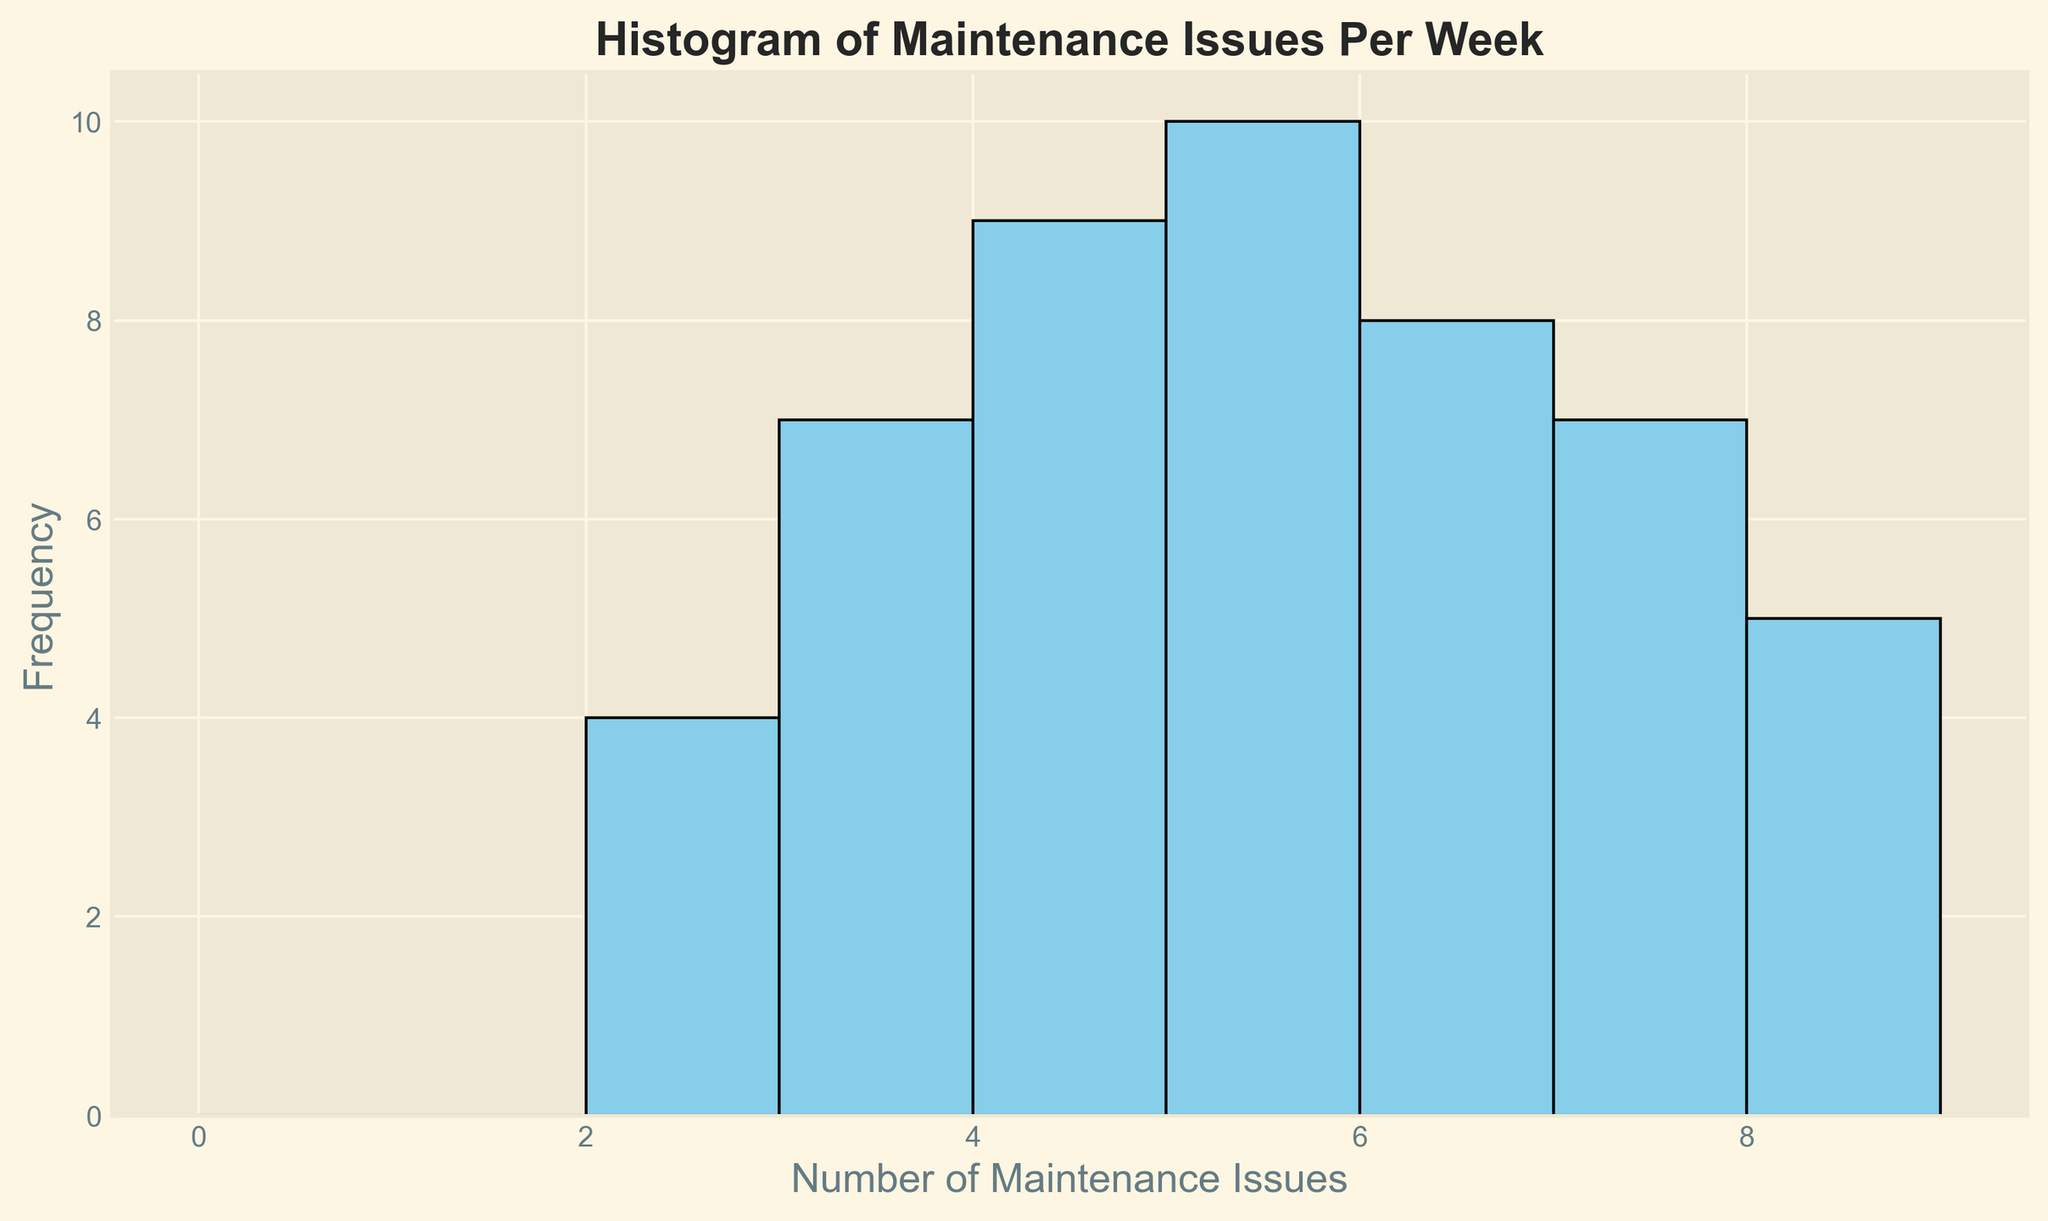What is the most frequent number of maintenance issues reported per week? Look at the histogram and identify the bar that is highest. The x-axis value corresponding to this bar indicates the most frequent number of maintenance issues.
Answer: 5 How many weeks had exactly 7 maintenance issues reported? Count the height of the bar above the number 7 on the x-axis. This number represents the frequency of 7 maintenance issues.
Answer: 6 Which number of maintenance issues is reported more frequently, 3 or 6? Compare the heights of the bars above the number 3 and the number 6 on the x-axis. The taller bar indicates the more frequent number of maintenance issues.
Answer: 6 What is the total number of weeks where the maintenance issues reported are less than 4? Sum the frequencies of the bars above the numbers 0, 1, 2, and 3 on the x-axis. This gives the total number of weeks for maintenance issues less than 4.
Answer: 9 Is the number of weeks with 8 maintenance issues higher than those with 2 maintenance issues? Compare the heights of the bars above the number 8 and the number 2 on the x-axis. Determine which is taller to see which is more frequent.
Answer: Yes What is the total frequency of weeks with 4 or fewer maintenance issues reported? Sum the heights of the bars above the numbers 0, 1, 2, 3, and 4 on the x-axis to get the total frequency for weeks with 4 or fewer maintenance issues.
Answer: 19 How does the frequency of weeks with 7 maintenance issues compare to those with 5 maintenance issues? Look at the heights of the bars above the numbers 7 and 5 on the x-axis. Compare these heights to determine which is more frequent.
Answer: The frequency is equal If a week is chosen at random, what is the likelihood that the number of maintenance issues will be 4 or 5? Add the heights of the bars above the numbers 4 and 5 on the x-axis. Divide this sum by the total number of weeks (50) to calculate the probability.
Answer: 0.36 What is the range of maintenance issues observed per week? Identify the minimum and maximum values on the x-axis with bars above them. Subtract the minimum value from the maximum value.
Answer: 8 